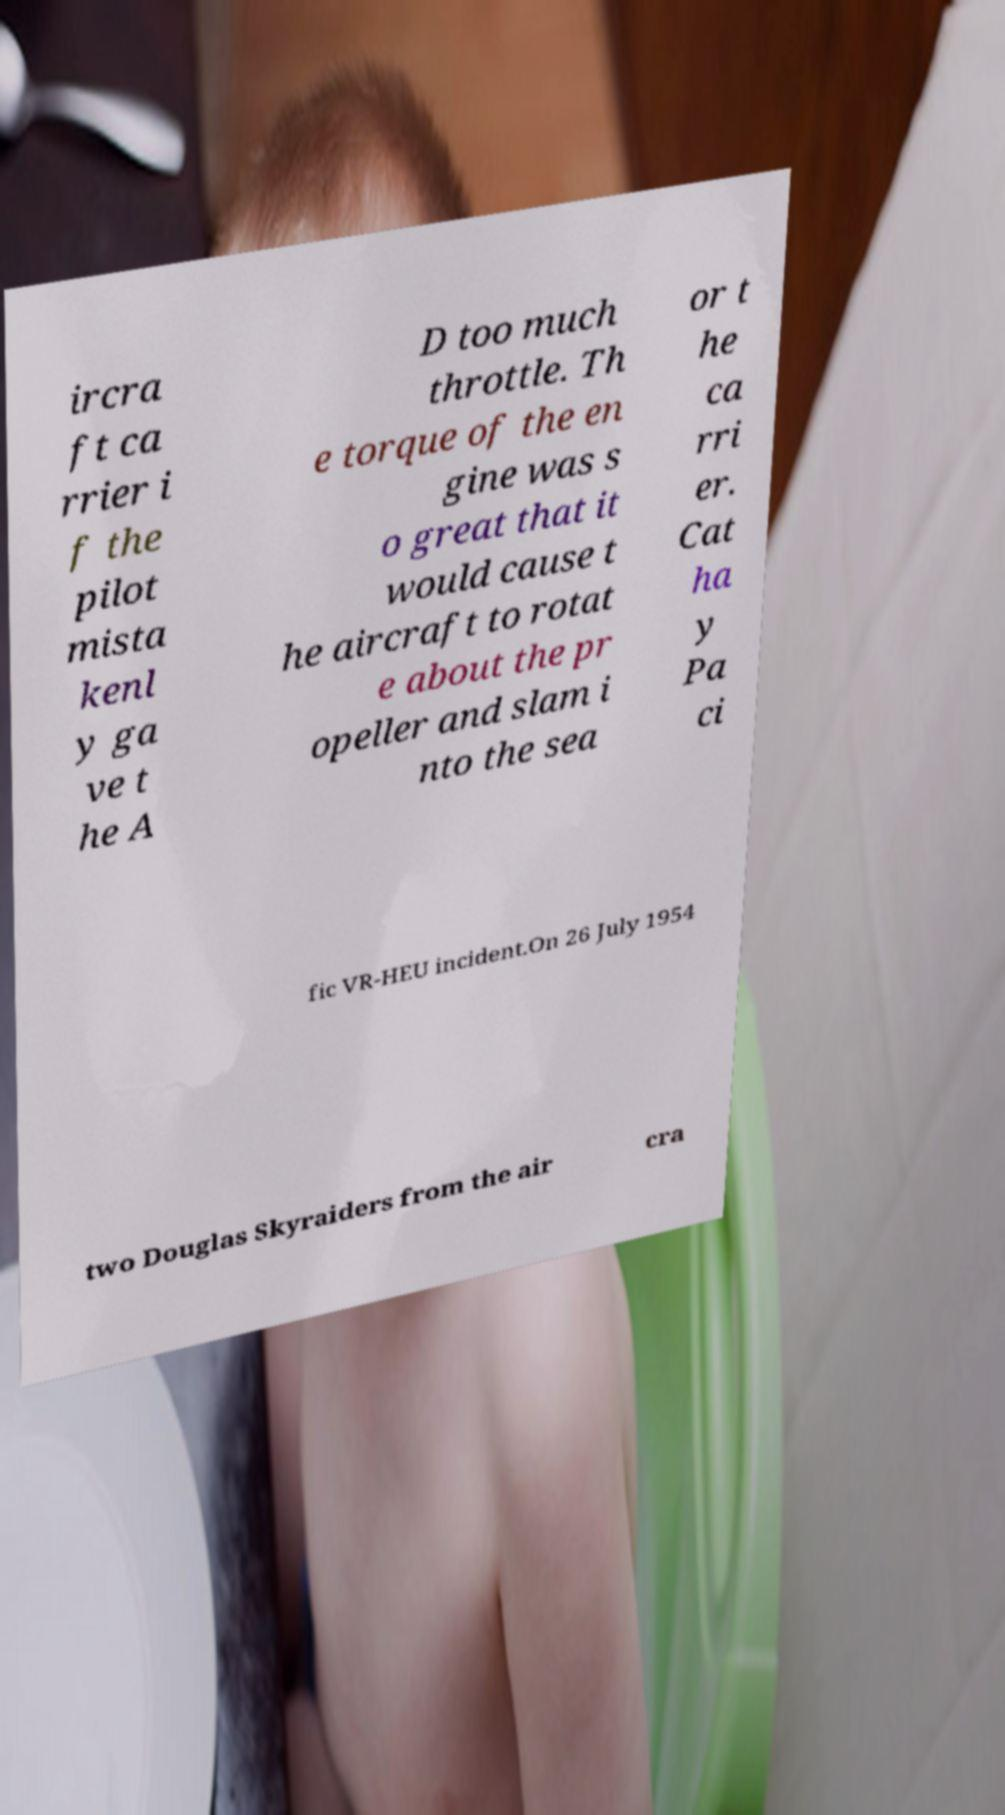I need the written content from this picture converted into text. Can you do that? ircra ft ca rrier i f the pilot mista kenl y ga ve t he A D too much throttle. Th e torque of the en gine was s o great that it would cause t he aircraft to rotat e about the pr opeller and slam i nto the sea or t he ca rri er. Cat ha y Pa ci fic VR-HEU incident.On 26 July 1954 two Douglas Skyraiders from the air cra 